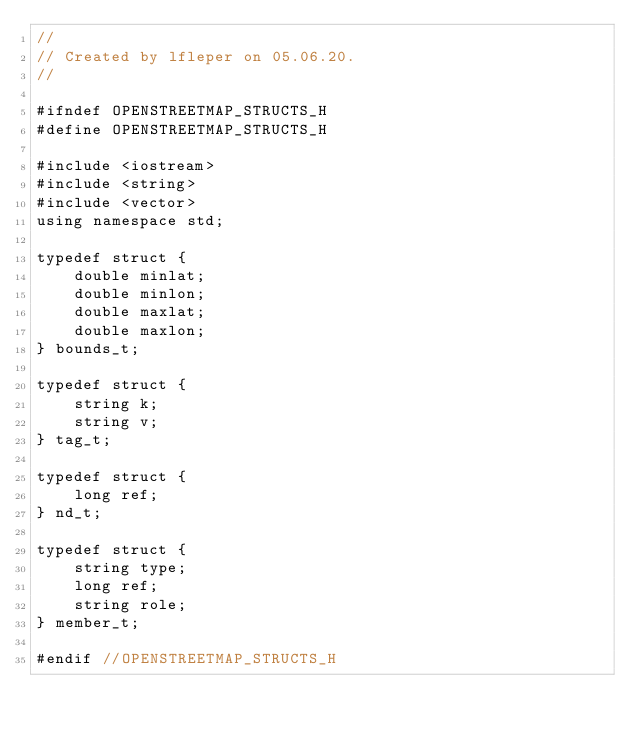Convert code to text. <code><loc_0><loc_0><loc_500><loc_500><_C_>//
// Created by lfleper on 05.06.20.
//

#ifndef OPENSTREETMAP_STRUCTS_H
#define OPENSTREETMAP_STRUCTS_H

#include <iostream>
#include <string>
#include <vector>
using namespace std;

typedef struct {
    double minlat;
    double minlon;
    double maxlat;
    double maxlon;
} bounds_t;

typedef struct {
    string k;
    string v;
} tag_t;

typedef struct {
    long ref;
} nd_t;

typedef struct {
    string type;
    long ref;
    string role;
} member_t;

#endif //OPENSTREETMAP_STRUCTS_H
</code> 